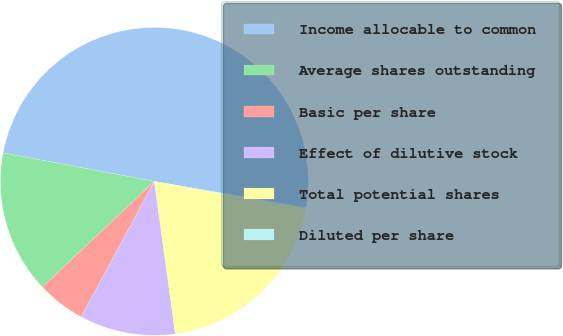<chart> <loc_0><loc_0><loc_500><loc_500><pie_chart><fcel>Income allocable to common<fcel>Average shares outstanding<fcel>Basic per share<fcel>Effect of dilutive stock<fcel>Total potential shares<fcel>Diluted per share<nl><fcel>49.77%<fcel>15.01%<fcel>5.08%<fcel>10.05%<fcel>19.98%<fcel>0.12%<nl></chart> 